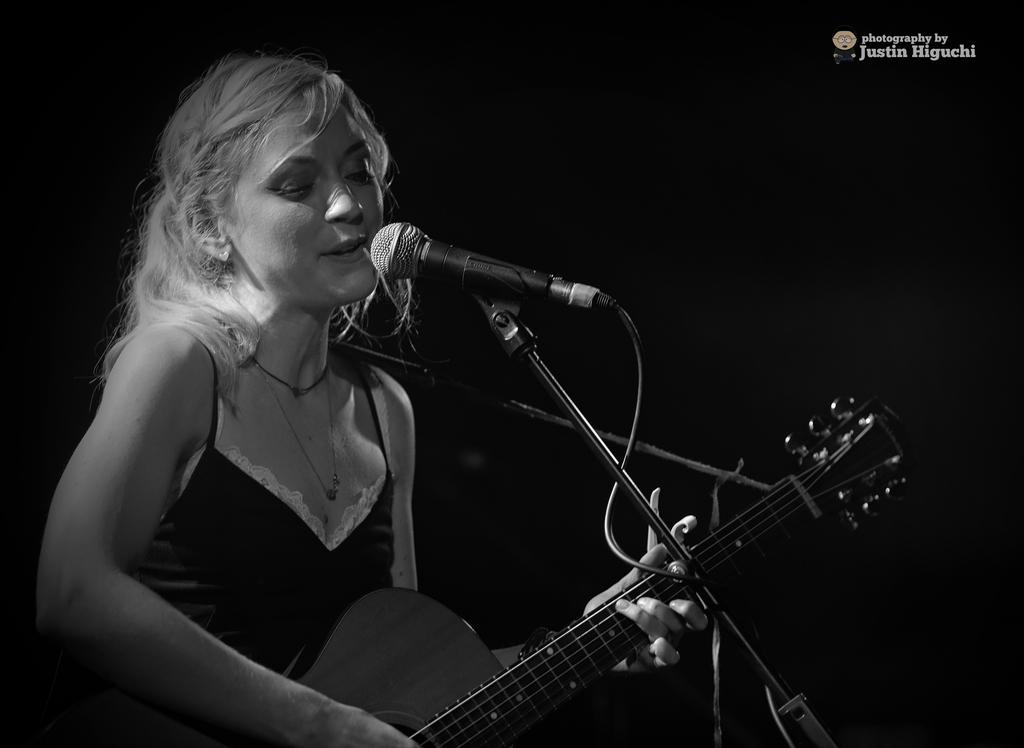Who is the main subject in the image? There is a woman in the image. What is the woman doing in the image? The woman is singing a song and playing a guitar. What object is the woman interacting with in the image? The woman is looking at a microphone. How is the microphone positioned in the image? The microphone is attached to a stand. How many dolls are sitting on the tree in the image? There are no dolls or trees present in the image. What type of soda is the woman holding in the image? There is no soda visible in the image; the woman is holding a microphone and playing a guitar. 